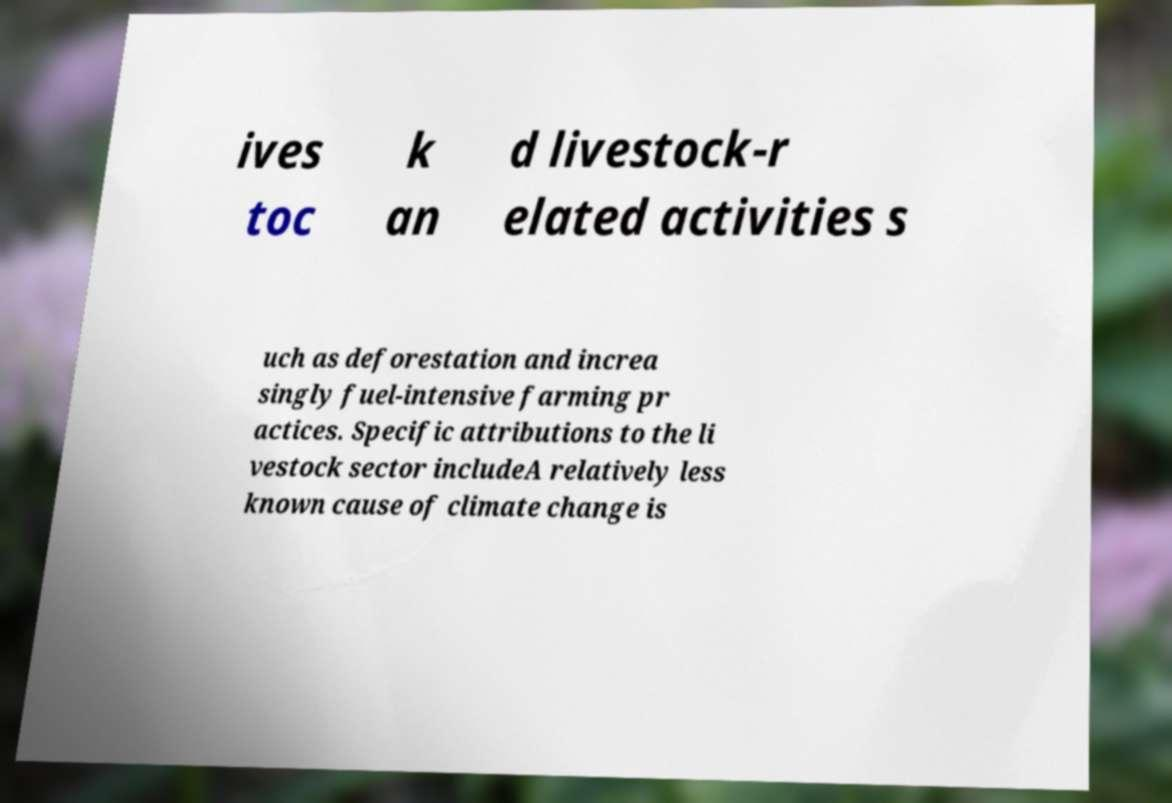Could you extract and type out the text from this image? ives toc k an d livestock-r elated activities s uch as deforestation and increa singly fuel-intensive farming pr actices. Specific attributions to the li vestock sector includeA relatively less known cause of climate change is 